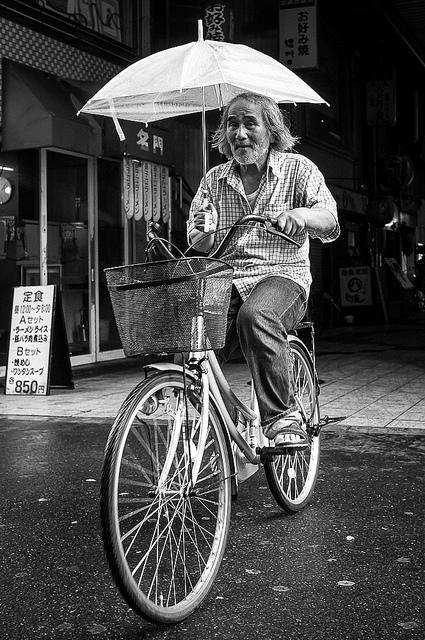How many bicycles can be seen?
Give a very brief answer. 1. 